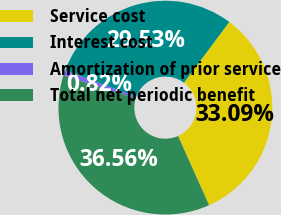Convert chart. <chart><loc_0><loc_0><loc_500><loc_500><pie_chart><fcel>Service cost<fcel>Interest cost<fcel>Amortization of prior service<fcel>Total net periodic benefit<nl><fcel>33.09%<fcel>29.53%<fcel>0.82%<fcel>36.56%<nl></chart> 